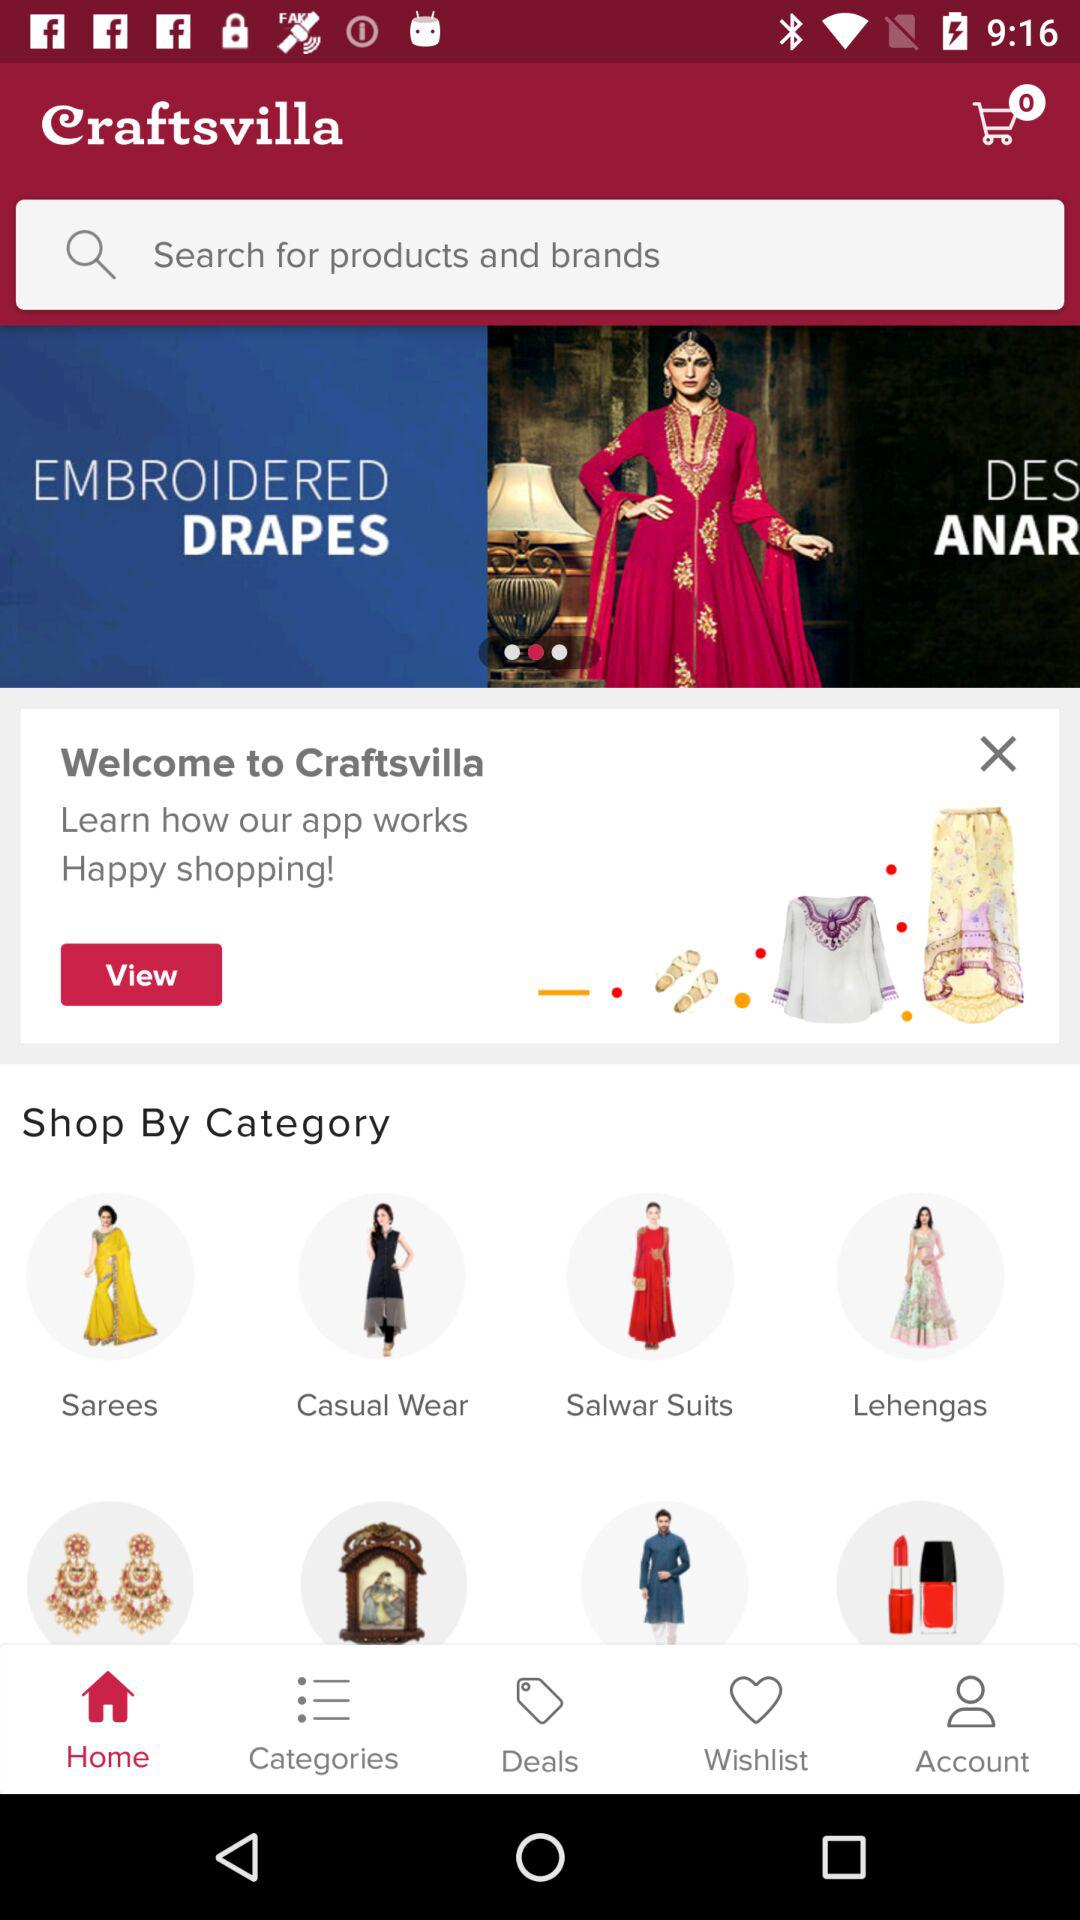What is the number of items in the cart? The number of items in the cart is 0. 